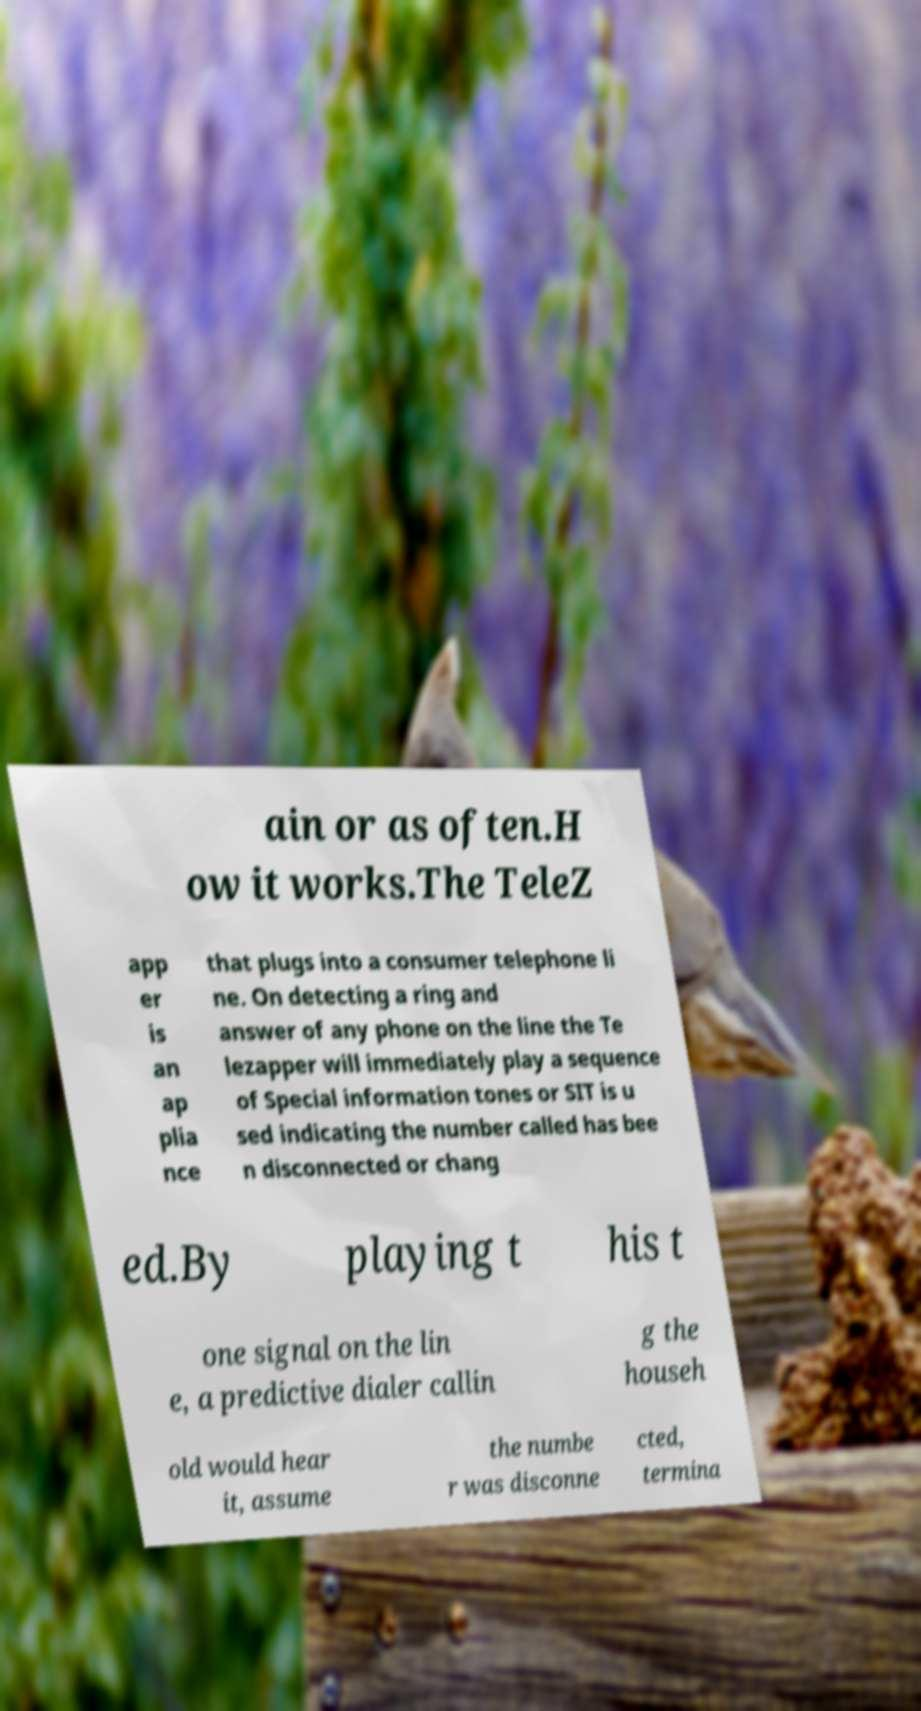There's text embedded in this image that I need extracted. Can you transcribe it verbatim? ain or as often.H ow it works.The TeleZ app er is an ap plia nce that plugs into a consumer telephone li ne. On detecting a ring and answer of any phone on the line the Te lezapper will immediately play a sequence of Special information tones or SIT is u sed indicating the number called has bee n disconnected or chang ed.By playing t his t one signal on the lin e, a predictive dialer callin g the househ old would hear it, assume the numbe r was disconne cted, termina 